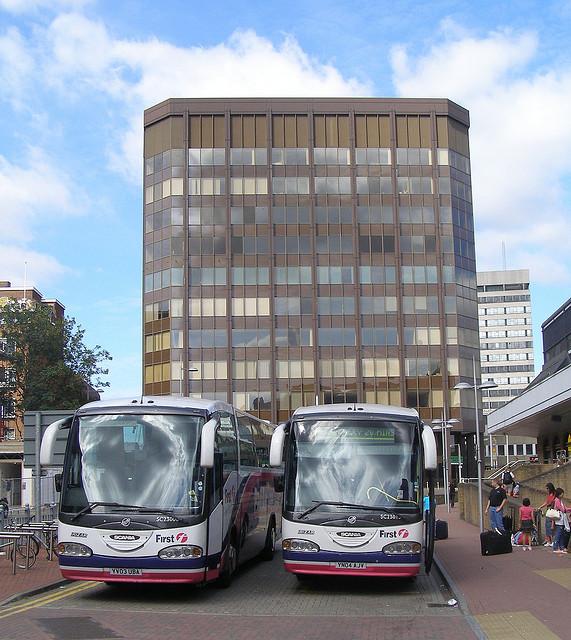How many buses are in the picture?
Keep it brief. 2. Are the buses identical?
Concise answer only. Yes. How many buildings are visible?
Give a very brief answer. 2. 